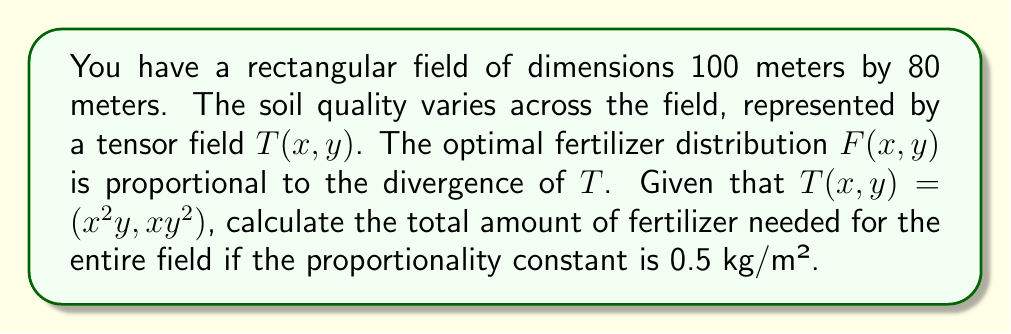Show me your answer to this math problem. Let's approach this step-by-step:

1) First, we need to calculate the divergence of $T(x,y)$:
   $$\text{div}(T) = \nabla \cdot T = \frac{\partial}{\partial x}(x^2y) + \frac{\partial}{\partial y}(xy^2)$$

2) Calculating the partial derivatives:
   $$\frac{\partial}{\partial x}(x^2y) = 2xy$$
   $$\frac{\partial}{\partial y}(xy^2) = 2xy$$

3) Therefore, the divergence is:
   $$\text{div}(T) = 2xy + 2xy = 4xy$$

4) The optimal fertilizer distribution $F(x,y)$ is proportional to this divergence:
   $$F(x,y) = 0.5 \cdot 4xy = 2xy \text{ kg/m²}$$

5) To find the total amount of fertilizer, we need to integrate this over the entire field:
   $$\text{Total Fertilizer} = \int_0^{80} \int_0^{100} 2xy \, dx \, dy$$

6) Solving the double integral:
   $$\begin{align}
   \text{Total Fertilizer} &= \int_0^{80} \left[ xy^2 \right]_0^{100} \, dy \\
   &= \int_0^{80} 100y^2 \, dy \\
   &= \left[ \frac{100y^3}{3} \right]_0^{80} \\
   &= \frac{100 \cdot 80^3}{3} \\
   &= 17,066,666.67 \text{ kg}
   \end{align}$$
Answer: 17,066,666.67 kg 